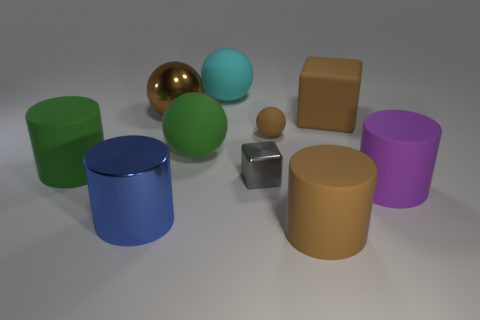Subtract all purple spheres. Subtract all green cylinders. How many spheres are left? 4 Subtract all blocks. How many objects are left? 8 Add 1 tiny brown balls. How many tiny brown balls are left? 2 Add 9 small cyan shiny objects. How many small cyan shiny objects exist? 9 Subtract 1 brown blocks. How many objects are left? 9 Subtract all brown metallic balls. Subtract all tiny brown things. How many objects are left? 8 